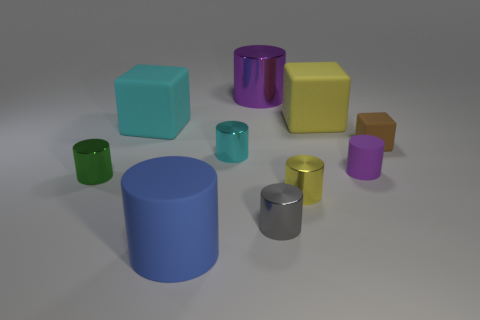Which objects in the image are cylindrical, and which are cubical? In the image, there are five cylindrical objects: a large blue one, a large purple one, a smaller green one, a smaller yellow one, and a smaller silver one. There are also five cubical objects: a large yellow one, a medium-sized green one, a small brown one, and a small purple one. 